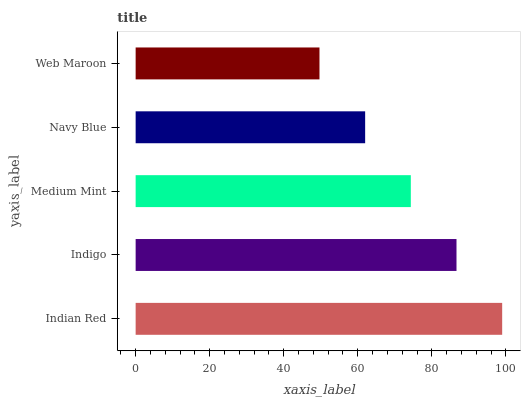Is Web Maroon the minimum?
Answer yes or no. Yes. Is Indian Red the maximum?
Answer yes or no. Yes. Is Indigo the minimum?
Answer yes or no. No. Is Indigo the maximum?
Answer yes or no. No. Is Indian Red greater than Indigo?
Answer yes or no. Yes. Is Indigo less than Indian Red?
Answer yes or no. Yes. Is Indigo greater than Indian Red?
Answer yes or no. No. Is Indian Red less than Indigo?
Answer yes or no. No. Is Medium Mint the high median?
Answer yes or no. Yes. Is Medium Mint the low median?
Answer yes or no. Yes. Is Indian Red the high median?
Answer yes or no. No. Is Web Maroon the low median?
Answer yes or no. No. 